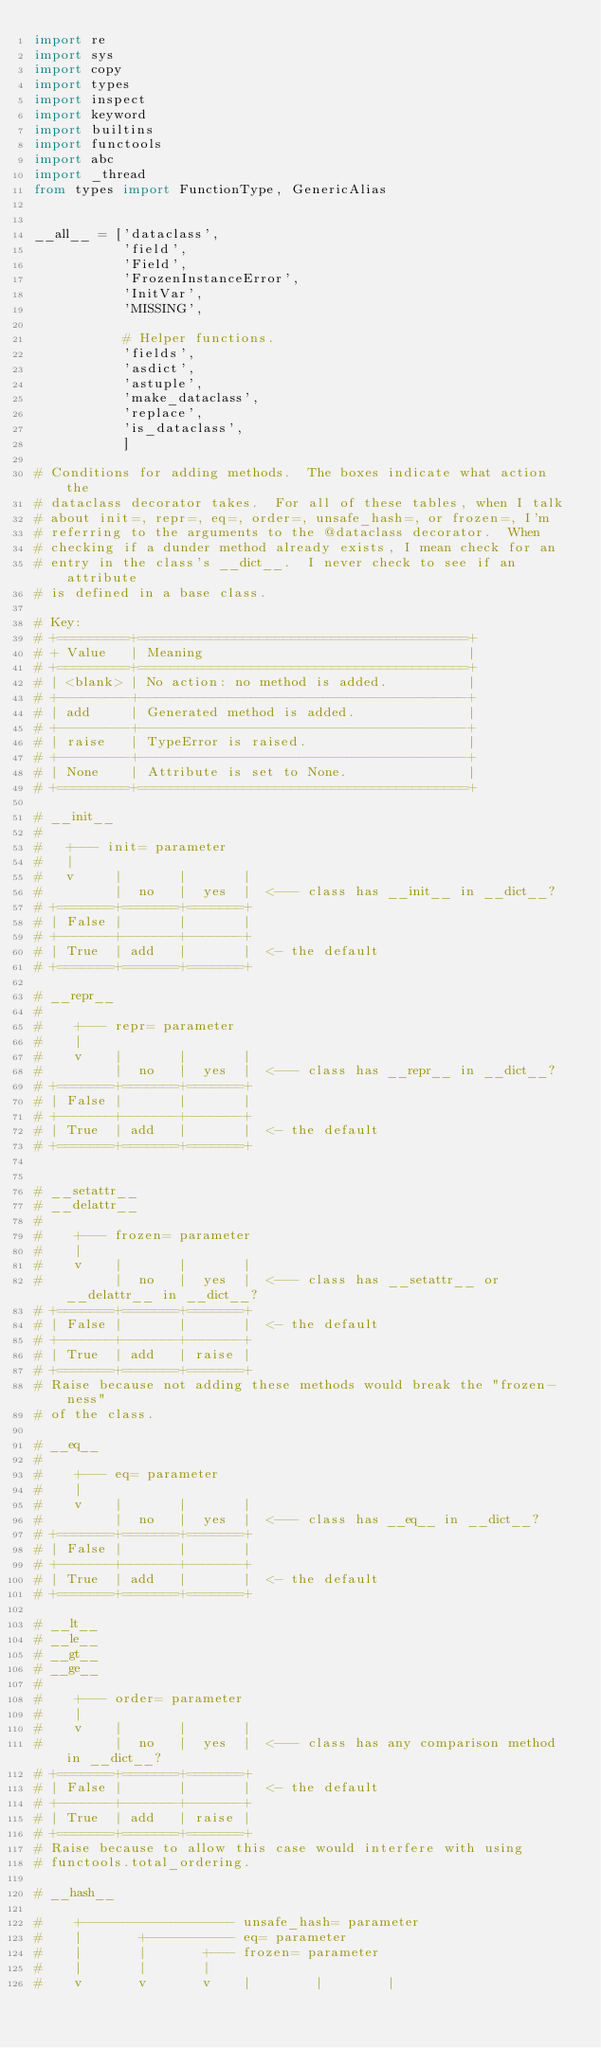Convert code to text. <code><loc_0><loc_0><loc_500><loc_500><_Python_>import re
import sys
import copy
import types
import inspect
import keyword
import builtins
import functools
import abc
import _thread
from types import FunctionType, GenericAlias


__all__ = ['dataclass',
           'field',
           'Field',
           'FrozenInstanceError',
           'InitVar',
           'MISSING',

           # Helper functions.
           'fields',
           'asdict',
           'astuple',
           'make_dataclass',
           'replace',
           'is_dataclass',
           ]

# Conditions for adding methods.  The boxes indicate what action the
# dataclass decorator takes.  For all of these tables, when I talk
# about init=, repr=, eq=, order=, unsafe_hash=, or frozen=, I'm
# referring to the arguments to the @dataclass decorator.  When
# checking if a dunder method already exists, I mean check for an
# entry in the class's __dict__.  I never check to see if an attribute
# is defined in a base class.

# Key:
# +=========+=========================================+
# + Value   | Meaning                                 |
# +=========+=========================================+
# | <blank> | No action: no method is added.          |
# +---------+-----------------------------------------+
# | add     | Generated method is added.              |
# +---------+-----------------------------------------+
# | raise   | TypeError is raised.                    |
# +---------+-----------------------------------------+
# | None    | Attribute is set to None.               |
# +=========+=========================================+

# __init__
#
#   +--- init= parameter
#   |
#   v     |       |       |
#         |  no   |  yes  |  <--- class has __init__ in __dict__?
# +=======+=======+=======+
# | False |       |       |
# +-------+-------+-------+
# | True  | add   |       |  <- the default
# +=======+=======+=======+

# __repr__
#
#    +--- repr= parameter
#    |
#    v    |       |       |
#         |  no   |  yes  |  <--- class has __repr__ in __dict__?
# +=======+=======+=======+
# | False |       |       |
# +-------+-------+-------+
# | True  | add   |       |  <- the default
# +=======+=======+=======+


# __setattr__
# __delattr__
#
#    +--- frozen= parameter
#    |
#    v    |       |       |
#         |  no   |  yes  |  <--- class has __setattr__ or __delattr__ in __dict__?
# +=======+=======+=======+
# | False |       |       |  <- the default
# +-------+-------+-------+
# | True  | add   | raise |
# +=======+=======+=======+
# Raise because not adding these methods would break the "frozen-ness"
# of the class.

# __eq__
#
#    +--- eq= parameter
#    |
#    v    |       |       |
#         |  no   |  yes  |  <--- class has __eq__ in __dict__?
# +=======+=======+=======+
# | False |       |       |
# +-------+-------+-------+
# | True  | add   |       |  <- the default
# +=======+=======+=======+

# __lt__
# __le__
# __gt__
# __ge__
#
#    +--- order= parameter
#    |
#    v    |       |       |
#         |  no   |  yes  |  <--- class has any comparison method in __dict__?
# +=======+=======+=======+
# | False |       |       |  <- the default
# +-------+-------+-------+
# | True  | add   | raise |
# +=======+=======+=======+
# Raise because to allow this case would interfere with using
# functools.total_ordering.

# __hash__

#    +------------------- unsafe_hash= parameter
#    |       +----------- eq= parameter
#    |       |       +--- frozen= parameter
#    |       |       |
#    v       v       v    |        |        |</code> 